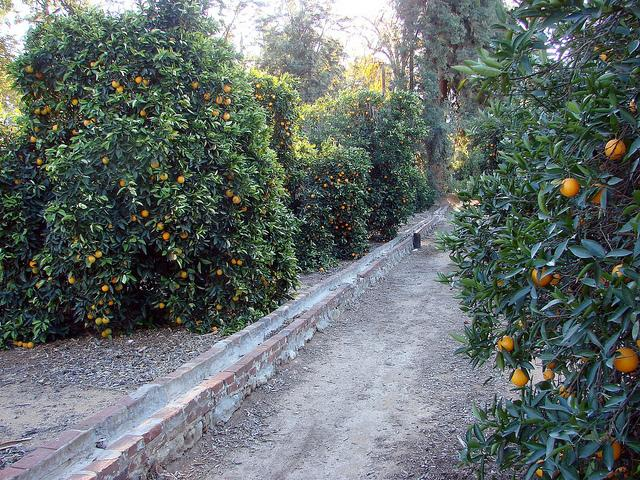What weather is greatest threat to this crop?

Choices:
A) rain
B) breeze
C) heat
D) freezing freezing 